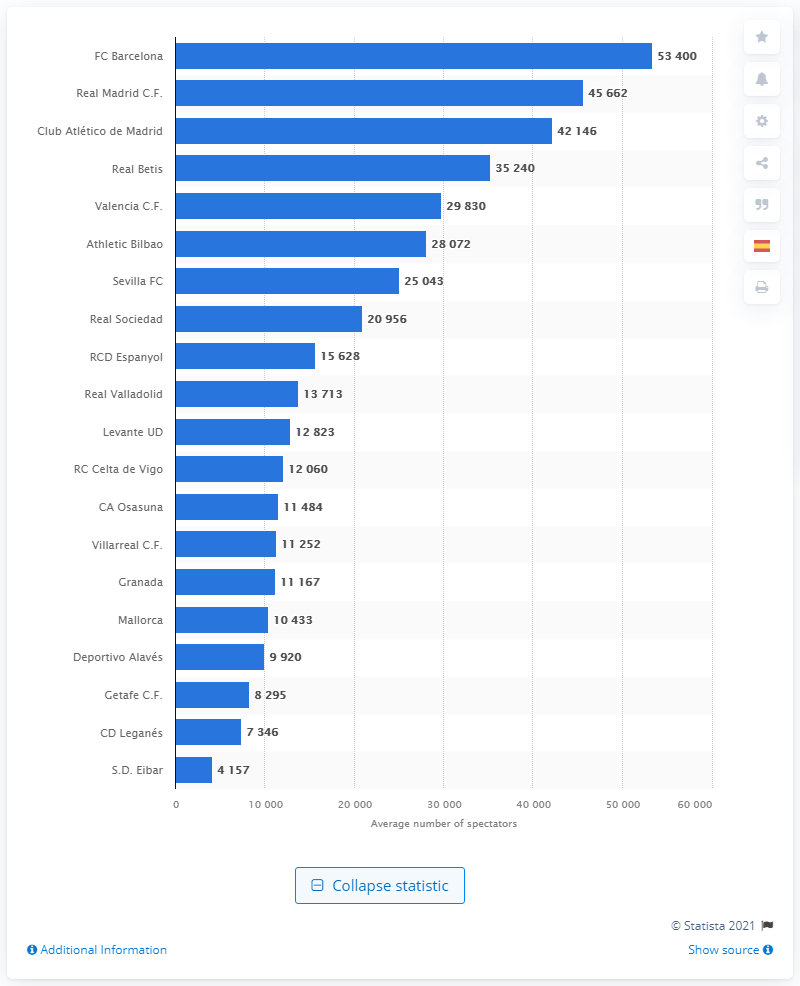List a handful of essential elements in this visual. In the 2019/2020 season, Real Madrid's Santiago Bernabu stadium was attended by a total of 45,662 spectators. During the 2019/2020 season, the average number of spectators at Camp Nou was 53,400. 